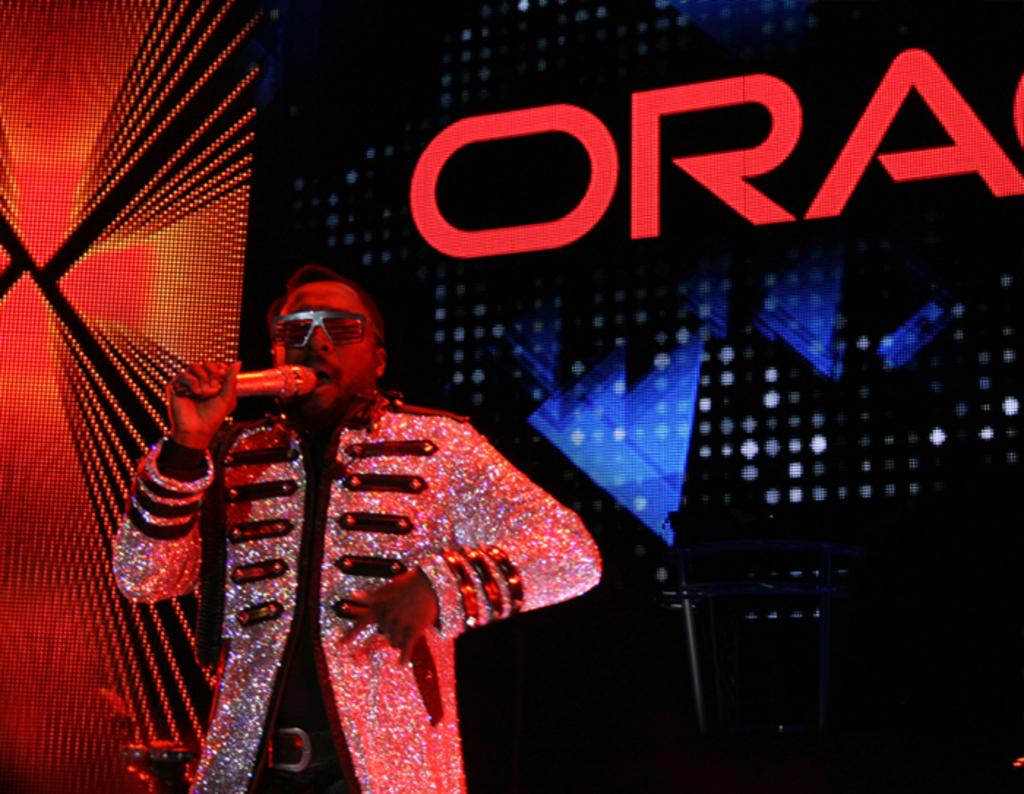What is the person in the image wearing? There is a person wearing a costume in the image. What is the person doing with the microphone? The person is speaking into a microphone. What can be seen in the background of the image? There is a digital screen in the image. What is displayed on the screen? There is text on the screen. Where is the drain located in the image? There is no drain present in the image. How many horses can be seen in the image? There are no horses present in the image. 